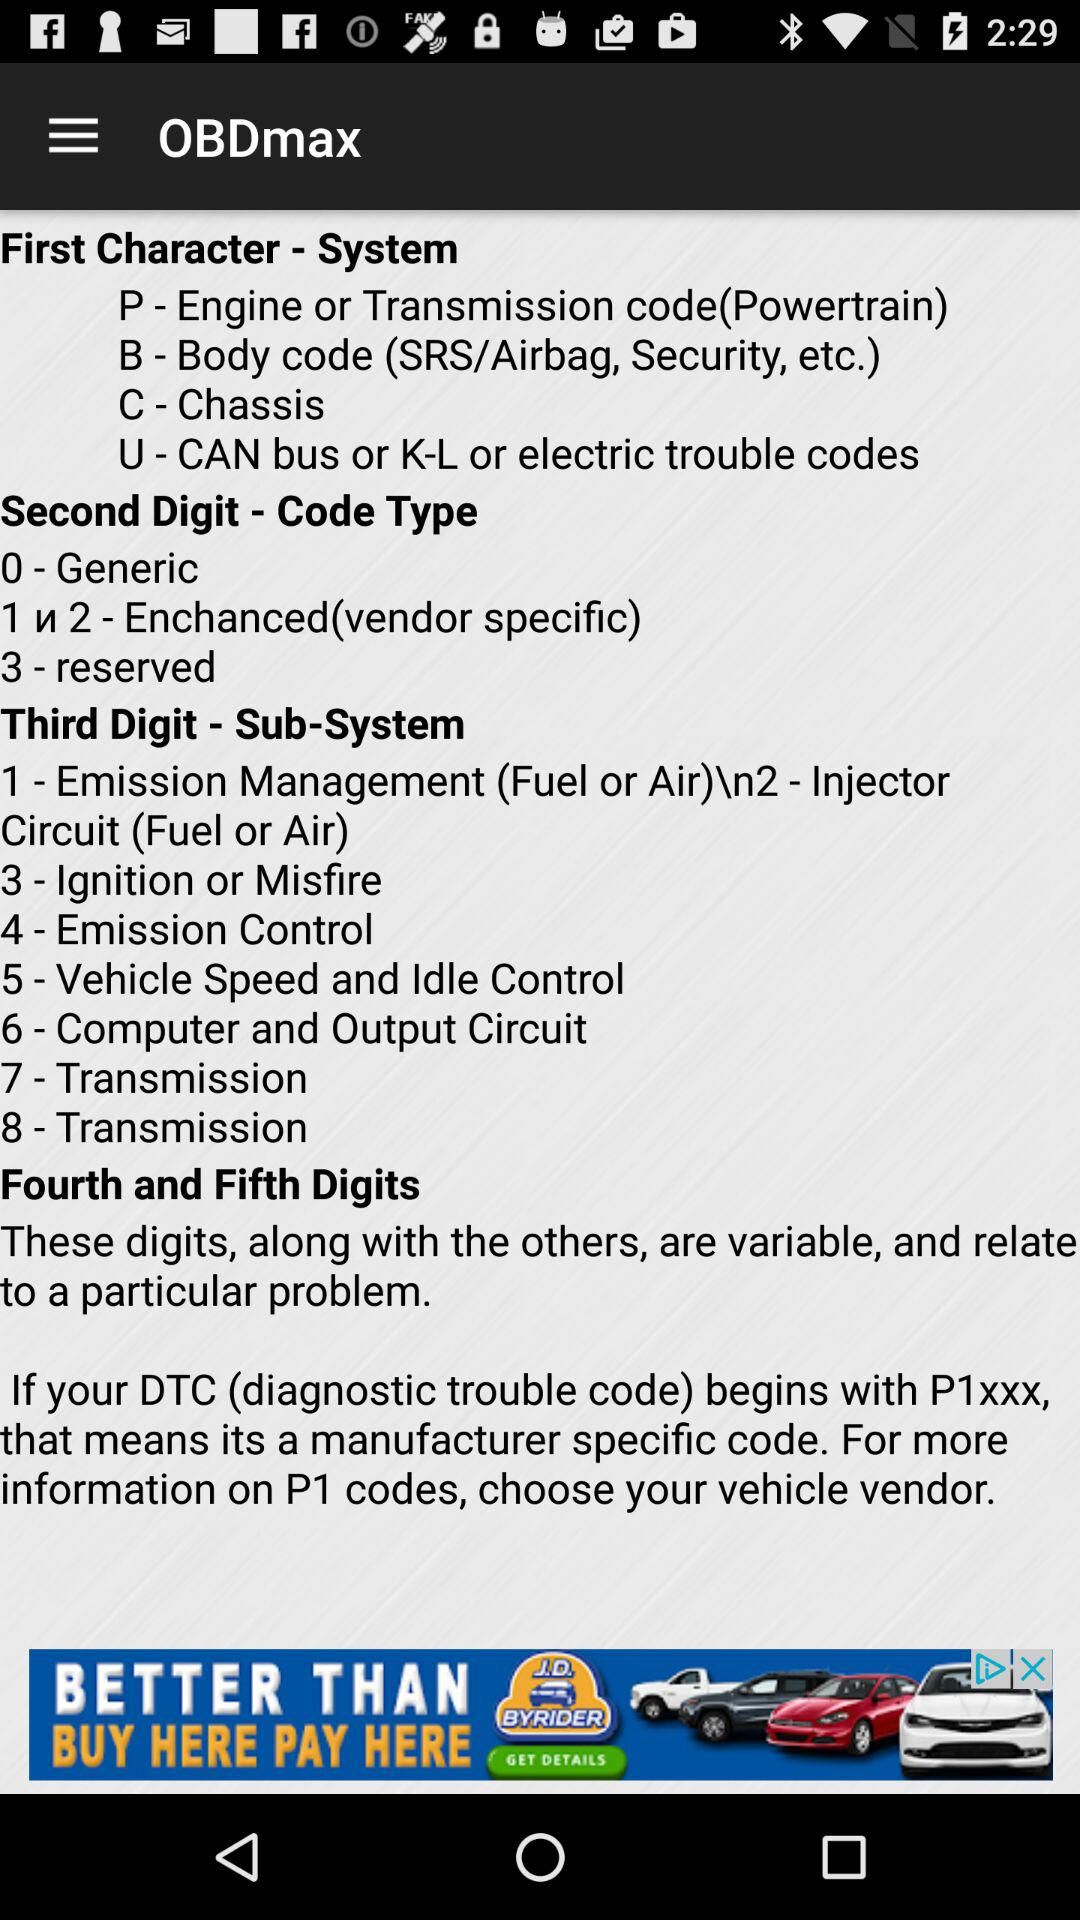How many digits are there in a P1 code?
Answer the question using a single word or phrase. 5 